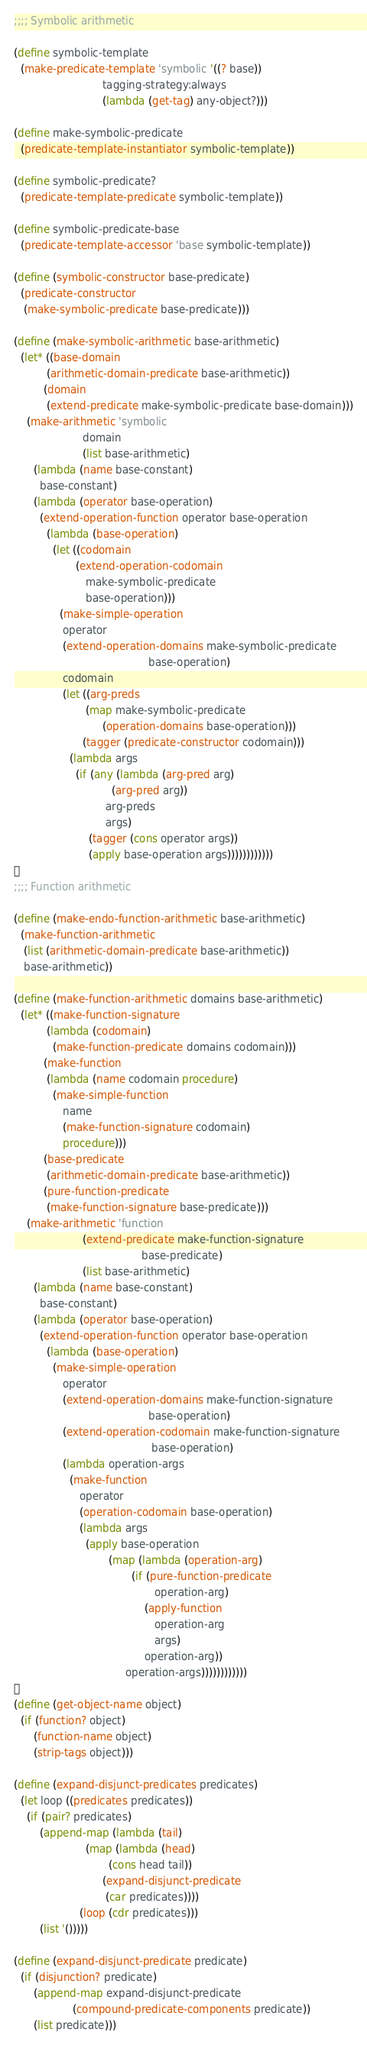Convert code to text. <code><loc_0><loc_0><loc_500><loc_500><_Scheme_>;;;; Symbolic arithmetic

(define symbolic-template
  (make-predicate-template 'symbolic '((? base))
                           tagging-strategy:always
                           (lambda (get-tag) any-object?)))

(define make-symbolic-predicate
  (predicate-template-instantiator symbolic-template))

(define symbolic-predicate?
  (predicate-template-predicate symbolic-template))

(define symbolic-predicate-base
  (predicate-template-accessor 'base symbolic-template))

(define (symbolic-constructor base-predicate)
  (predicate-constructor
   (make-symbolic-predicate base-predicate)))

(define (make-symbolic-arithmetic base-arithmetic)
  (let* ((base-domain
          (arithmetic-domain-predicate base-arithmetic))
         (domain
          (extend-predicate make-symbolic-predicate base-domain)))
    (make-arithmetic 'symbolic
                     domain
                     (list base-arithmetic)
      (lambda (name base-constant)
        base-constant)
      (lambda (operator base-operation)
        (extend-operation-function operator base-operation
          (lambda (base-operation)
            (let ((codomain
                   (extend-operation-codomain
                      make-symbolic-predicate
                      base-operation)))
              (make-simple-operation
               operator
               (extend-operation-domains make-symbolic-predicate
                                         base-operation)
               codomain
               (let ((arg-preds
                      (map make-symbolic-predicate
                           (operation-domains base-operation)))
                     (tagger (predicate-constructor codomain)))
                 (lambda args
                   (if (any (lambda (arg-pred arg)
                              (arg-pred arg))
                            arg-preds
                            args)
                       (tagger (cons operator args))
                       (apply base-operation args))))))))))))

;;;; Function arithmetic

(define (make-endo-function-arithmetic base-arithmetic)
  (make-function-arithmetic
   (list (arithmetic-domain-predicate base-arithmetic))
   base-arithmetic))

(define (make-function-arithmetic domains base-arithmetic)
  (let* ((make-function-signature
          (lambda (codomain)
            (make-function-predicate domains codomain)))
         (make-function
          (lambda (name codomain procedure)
            (make-simple-function
               name
               (make-function-signature codomain)
               procedure)))
         (base-predicate
          (arithmetic-domain-predicate base-arithmetic))
         (pure-function-predicate
          (make-function-signature base-predicate)))
    (make-arithmetic 'function
                     (extend-predicate make-function-signature
                                       base-predicate)
                     (list base-arithmetic)
      (lambda (name base-constant)
        base-constant)
      (lambda (operator base-operation)
        (extend-operation-function operator base-operation
          (lambda (base-operation)
            (make-simple-operation
               operator
               (extend-operation-domains make-function-signature
                                         base-operation)
               (extend-operation-codomain make-function-signature
                                          base-operation)
               (lambda operation-args
                 (make-function
                    operator
                    (operation-codomain base-operation)
                    (lambda args
                      (apply base-operation
                             (map (lambda (operation-arg)
                                    (if (pure-function-predicate
                                           operation-arg)
                                        (apply-function
                                           operation-arg
                                           args)
                                        operation-arg))
                                  operation-args))))))))))))

(define (get-object-name object)
  (if (function? object)
      (function-name object)
      (strip-tags object)))

(define (expand-disjunct-predicates predicates)
  (let loop ((predicates predicates))
    (if (pair? predicates)
        (append-map (lambda (tail)
                      (map (lambda (head)
                             (cons head tail))
                           (expand-disjunct-predicate
                            (car predicates))))
                    (loop (cdr predicates)))
        (list '()))))

(define (expand-disjunct-predicate predicate)
  (if (disjunction? predicate)
      (append-map expand-disjunct-predicate
                  (compound-predicate-components predicate))
      (list predicate)))</code> 